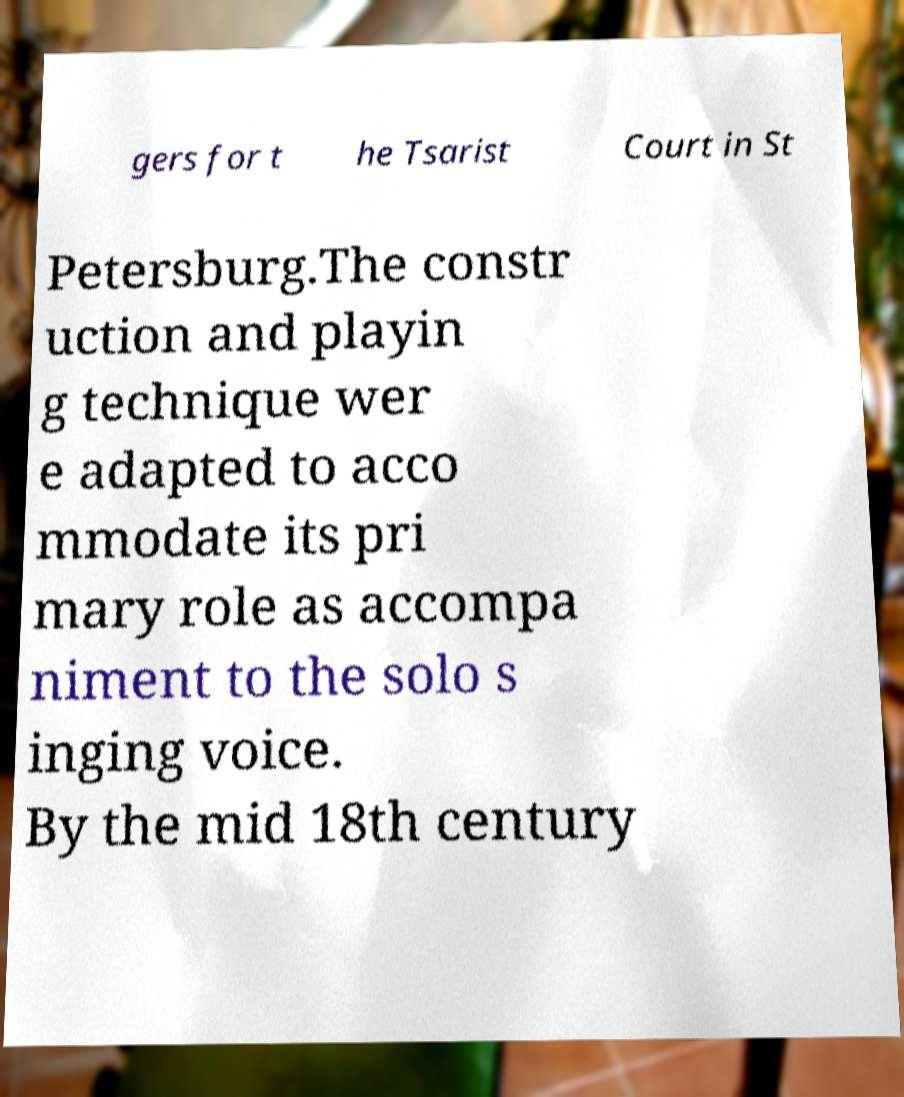I need the written content from this picture converted into text. Can you do that? gers for t he Tsarist Court in St Petersburg.The constr uction and playin g technique wer e adapted to acco mmodate its pri mary role as accompa niment to the solo s inging voice. By the mid 18th century 